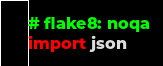<code> <loc_0><loc_0><loc_500><loc_500><_Python_># flake8: noqa
import json
</code> 